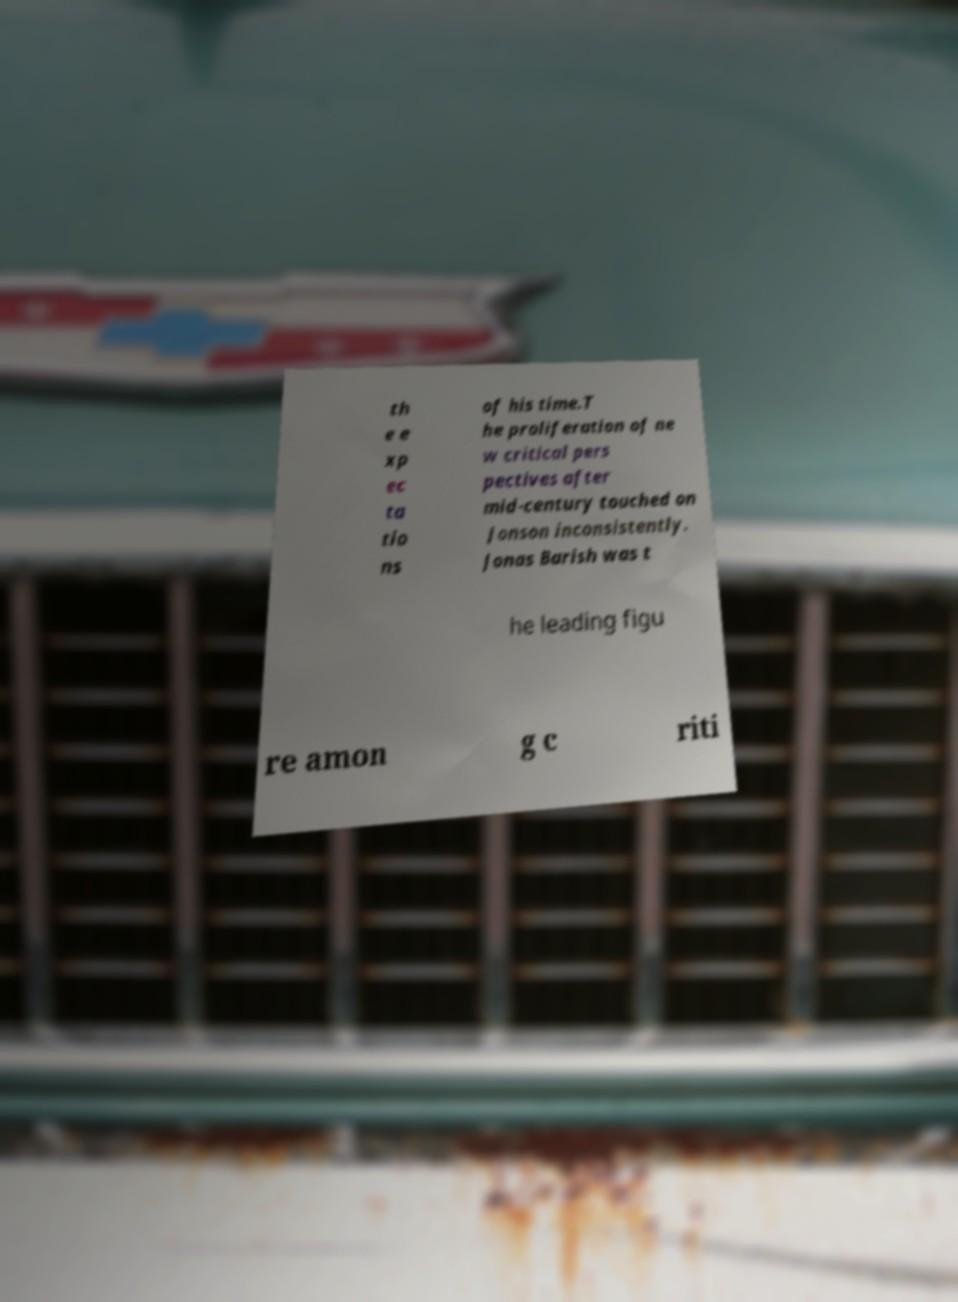Can you accurately transcribe the text from the provided image for me? th e e xp ec ta tio ns of his time.T he proliferation of ne w critical pers pectives after mid-century touched on Jonson inconsistently. Jonas Barish was t he leading figu re amon g c riti 